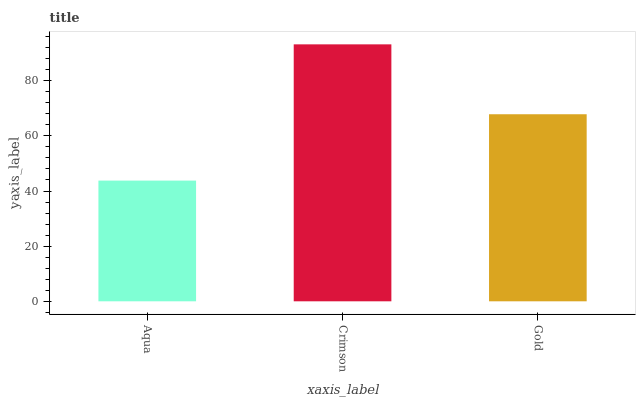Is Gold the minimum?
Answer yes or no. No. Is Gold the maximum?
Answer yes or no. No. Is Crimson greater than Gold?
Answer yes or no. Yes. Is Gold less than Crimson?
Answer yes or no. Yes. Is Gold greater than Crimson?
Answer yes or no. No. Is Crimson less than Gold?
Answer yes or no. No. Is Gold the high median?
Answer yes or no. Yes. Is Gold the low median?
Answer yes or no. Yes. Is Crimson the high median?
Answer yes or no. No. Is Crimson the low median?
Answer yes or no. No. 